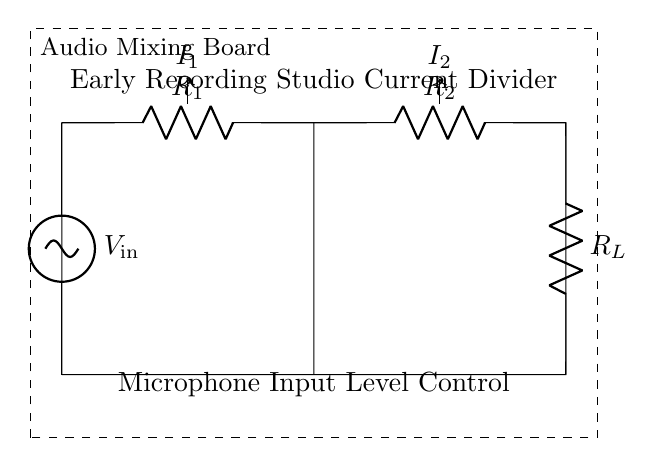What is the input voltage in the circuit? The input voltage is labeled as V_in in the diagram and represents the voltage supplied to the circuit.
Answer: V_in What are the resistances in the circuit? The circuit contains three resistors: R1, R2, and R_L, which are indicated on the diagram.
Answer: R1, R2, R_L What happens to the current through R1 and R2? The total current entering the circuit divides into two branches, one passing through R1 and the other through R2, creating two distinct currents: I1 and I2.
Answer: It divides How does the current divider principle apply here? According to the current divider principle, the current flowing through each resistance is inversely proportional to its resistance value. The more resistance one branch has, the less current it will carry compared to a branch with less resistance.
Answer: Inversely proportional What is the relationship between I1 and I2? I1 and I2 relate to the input current based on their respective resistances; they sum to equal the input current I_total. Specifically, I1 would be given by the formula for the current divider rule, where I_total is shared based on the ratios of R2 and R1.
Answer: I1 + I2 = I_total What does R_L represent in the context of the circuit? R_L represents the load resistor connected at the output side, which could represent the load that the mixing board is driving, affecting the overall current and voltage levels in the circuit.
Answer: Load resistor What component primarily controls the microphone input levels? The resistors R1 and R2 are primarily responsible for controlling the levels of the input current from the microphone, affecting how much signal reaches the next stage in the mixing board.
Answer: Resistors R1 and R2 